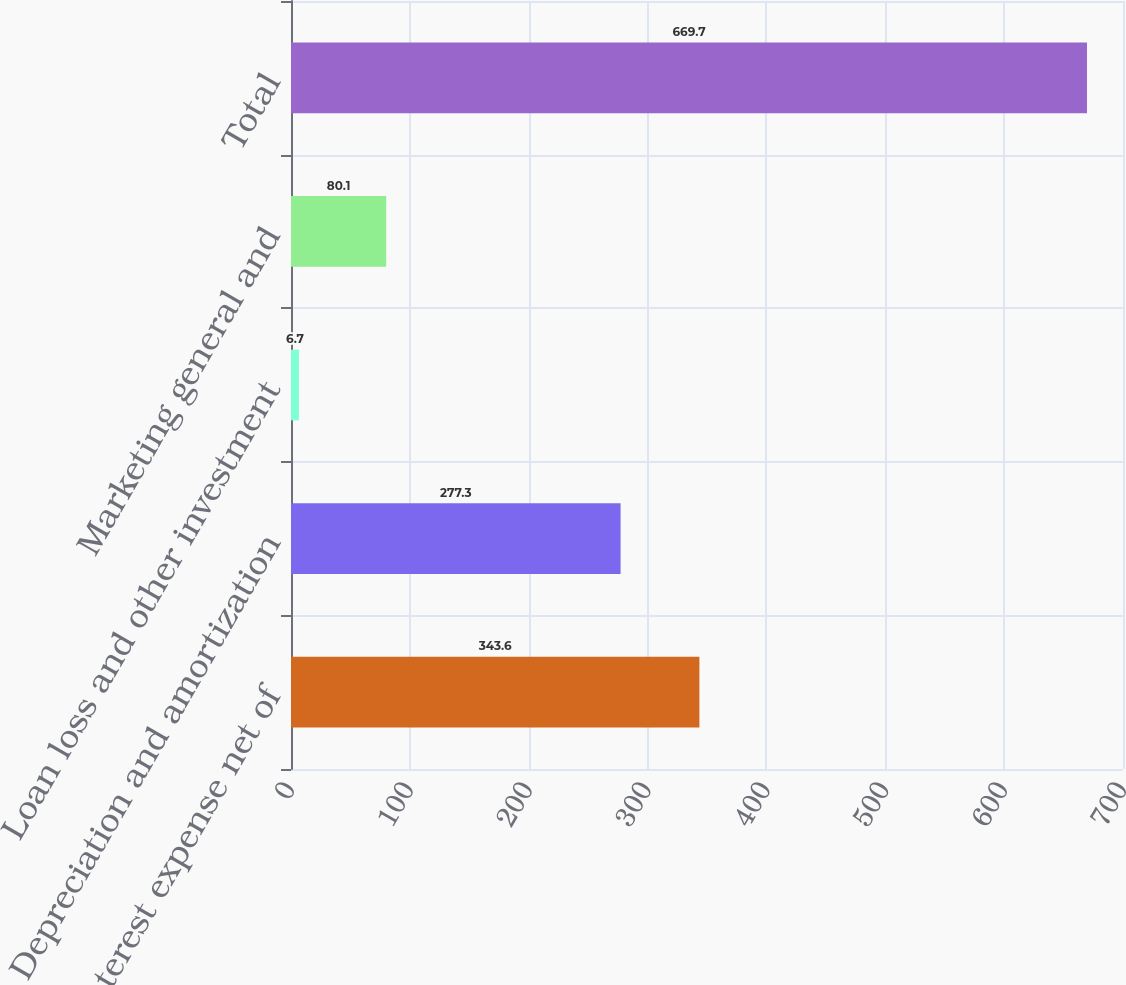Convert chart to OTSL. <chart><loc_0><loc_0><loc_500><loc_500><bar_chart><fcel>Interest expense net of<fcel>Depreciation and amortization<fcel>Loan loss and other investment<fcel>Marketing general and<fcel>Total<nl><fcel>343.6<fcel>277.3<fcel>6.7<fcel>80.1<fcel>669.7<nl></chart> 